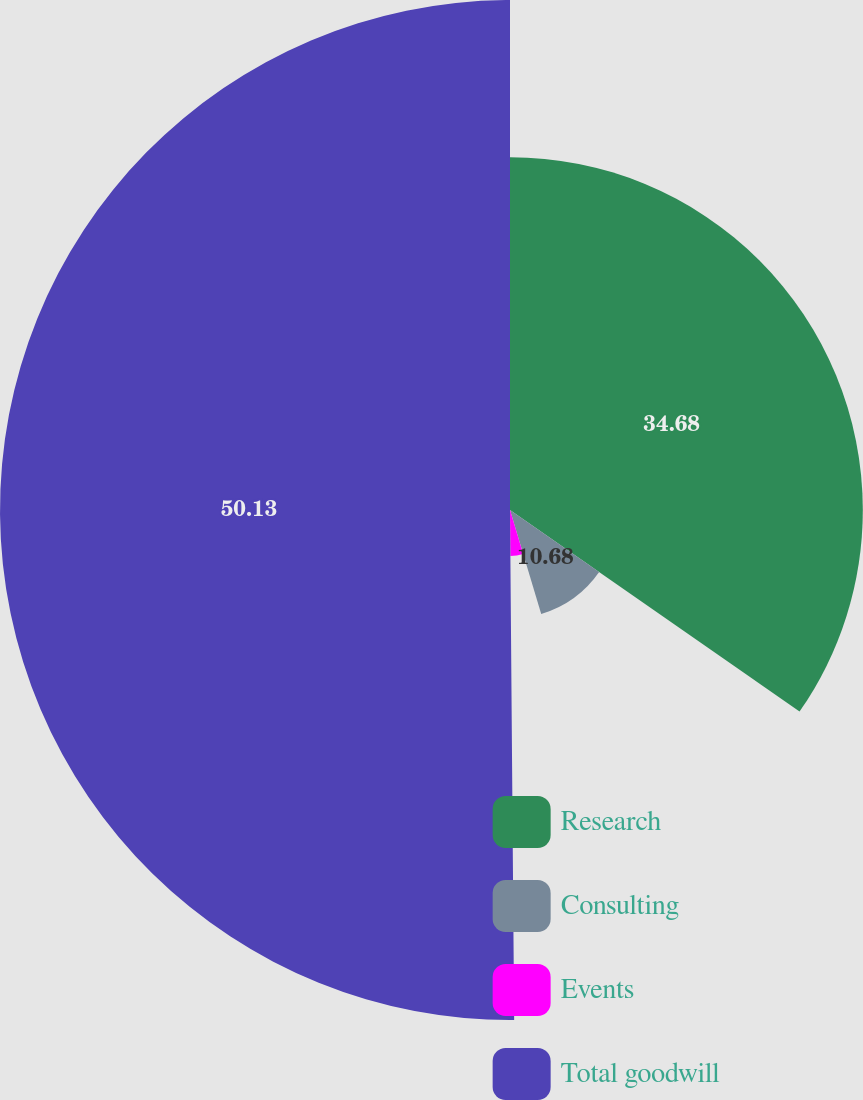<chart> <loc_0><loc_0><loc_500><loc_500><pie_chart><fcel>Research<fcel>Consulting<fcel>Events<fcel>Total goodwill<nl><fcel>34.68%<fcel>10.68%<fcel>4.51%<fcel>50.13%<nl></chart> 